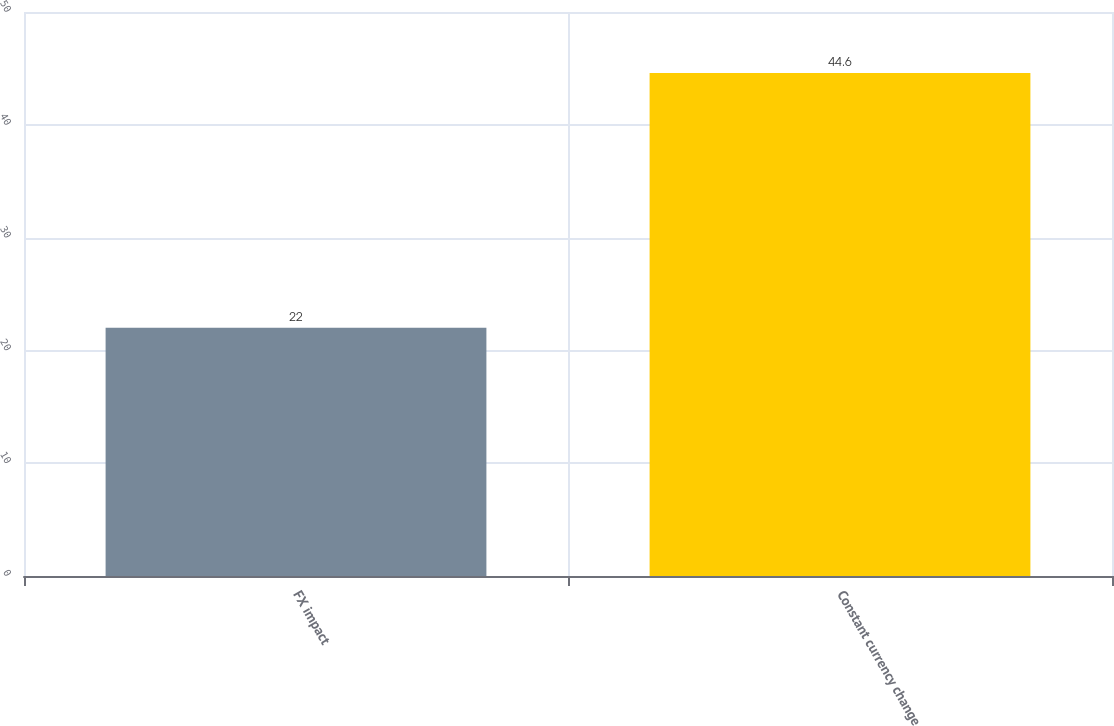Convert chart. <chart><loc_0><loc_0><loc_500><loc_500><bar_chart><fcel>FX impact<fcel>Constant currency change<nl><fcel>22<fcel>44.6<nl></chart> 